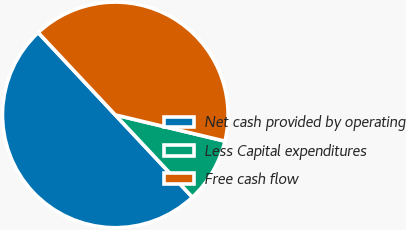Convert chart to OTSL. <chart><loc_0><loc_0><loc_500><loc_500><pie_chart><fcel>Net cash provided by operating<fcel>Less Capital expenditures<fcel>Free cash flow<nl><fcel>50.0%<fcel>9.28%<fcel>40.72%<nl></chart> 